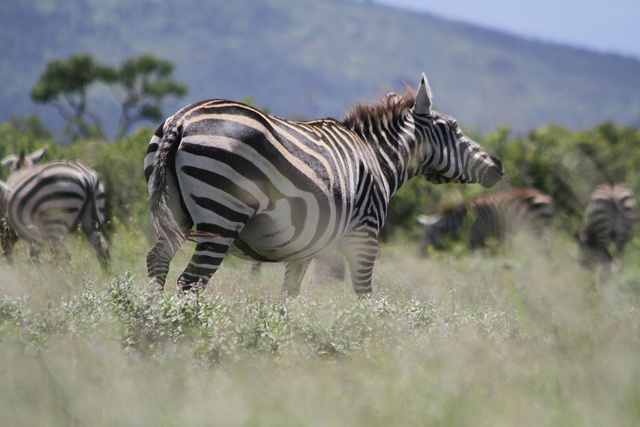Describe the objects in this image and their specific colors. I can see zebra in gray, black, and darkgray tones, zebra in gray, black, and darkgray tones, zebra in gray, black, and darkgreen tones, and zebra in gray, black, and darkgray tones in this image. 